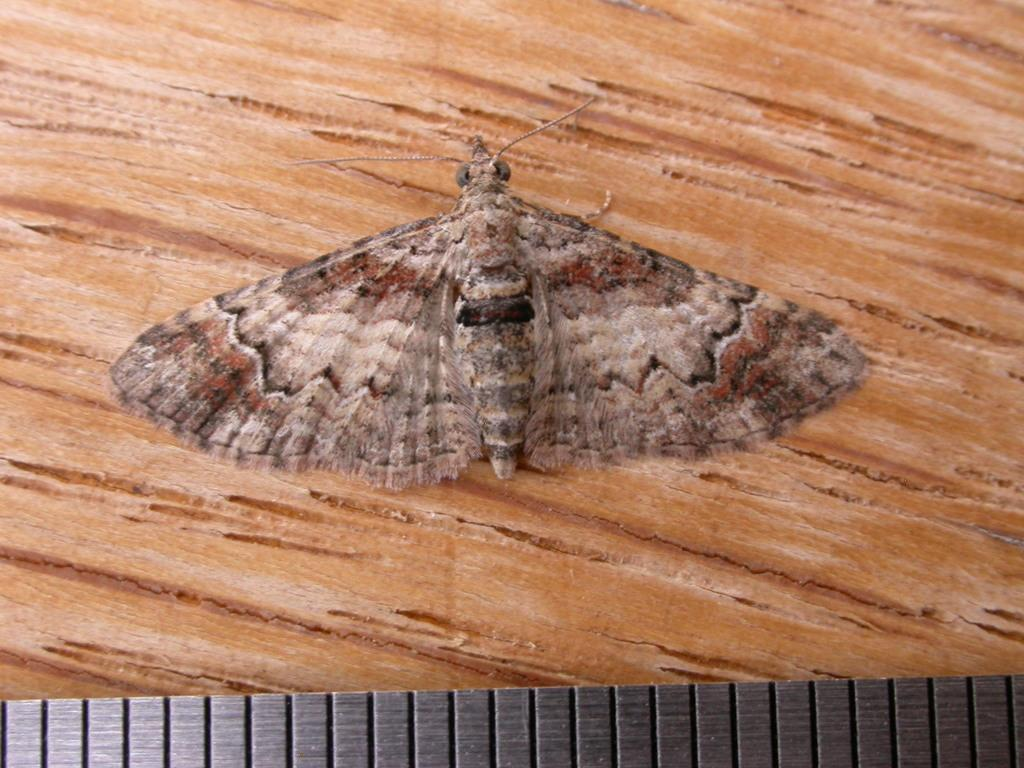What is present on the wooden surface in the image? There is a fly on a wooden surface in the image. Can you describe the black object in the image? Unfortunately, there is not enough information provided to describe the black object in the image. What is the writer doing in the image? There is no writer present in the image; it only features a fly on a wooden surface and an unspecified black object. 